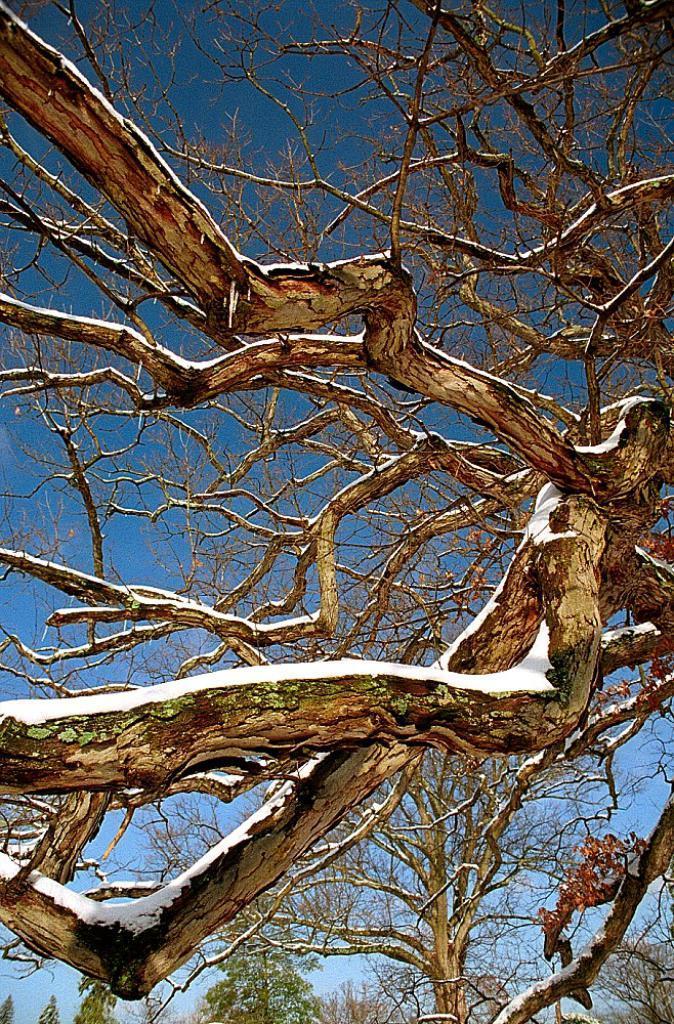Describe this image in one or two sentences. In this picture there is a dry tree branches in the middle of the image. Behind there is a blue sky. 